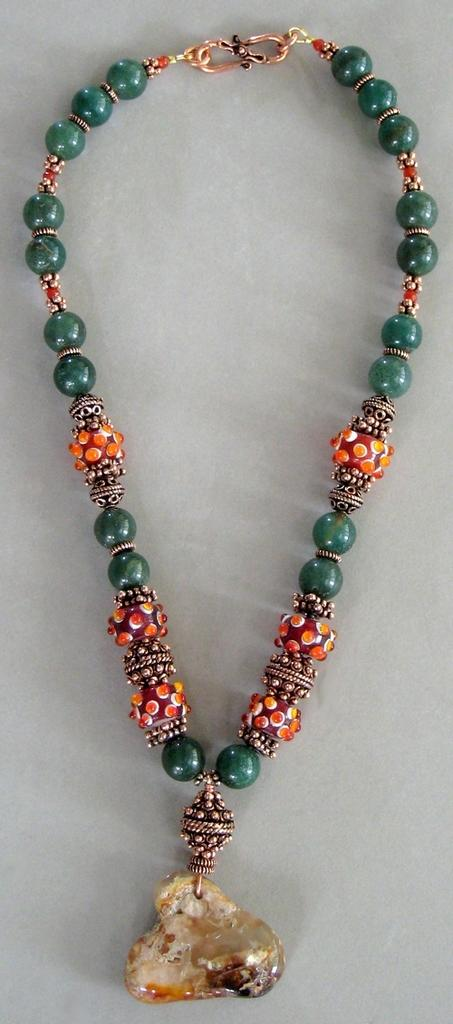What type of image is being shown? The image is a zoomed-in picture. What object can be seen in the zoomed-in image? There is a locket chain in the image. Where is the locket chain located? The locket chain is placed on a surface. What type of arithmetic problem is being solved in the image? There is no arithmetic problem present in the image; it features a locket chain placed on a surface. 